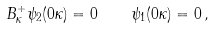<formula> <loc_0><loc_0><loc_500><loc_500>B _ { \kappa } ^ { + } \psi _ { 2 } ( 0 \kappa ) = 0 \quad \psi _ { 1 } ( 0 \kappa ) = 0 \, ,</formula> 